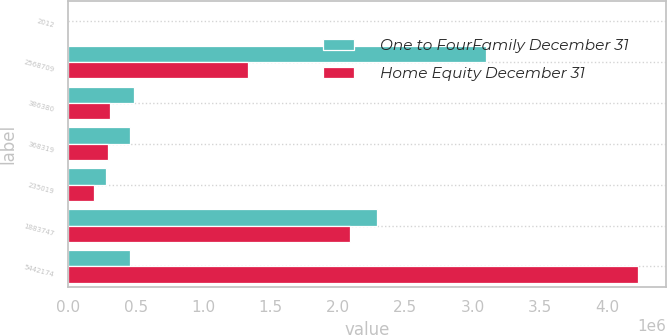Convert chart. <chart><loc_0><loc_0><loc_500><loc_500><stacked_bar_chart><ecel><fcel>2012<fcel>2568709<fcel>386380<fcel>368319<fcel>235019<fcel>1883747<fcel>5442174<nl><fcel>One to FourFamily December 31<fcel>2011<fcel>3.09603e+06<fcel>488209<fcel>458219<fcel>280772<fcel>2.29258e+06<fcel>458219<nl><fcel>Home Equity December 31<fcel>2012<fcel>1.33332e+06<fcel>313148<fcel>298860<fcel>192143<fcel>2.08599e+06<fcel>4.22346e+06<nl></chart> 